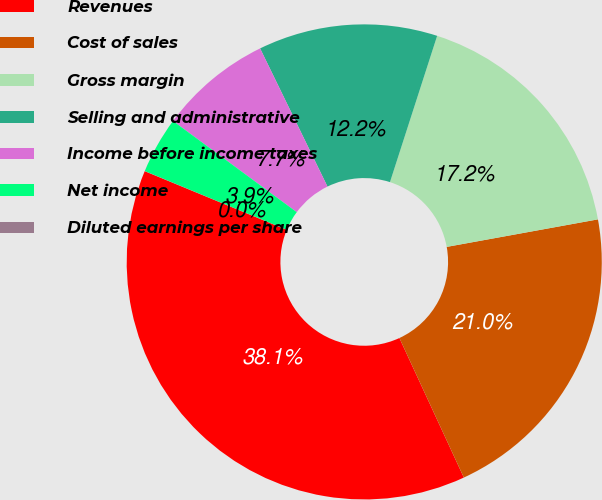Convert chart to OTSL. <chart><loc_0><loc_0><loc_500><loc_500><pie_chart><fcel>Revenues<fcel>Cost of sales<fcel>Gross margin<fcel>Selling and administrative<fcel>Income before income taxes<fcel>Net income<fcel>Diluted earnings per share<nl><fcel>38.13%<fcel>20.98%<fcel>17.17%<fcel>12.19%<fcel>7.67%<fcel>3.86%<fcel>0.01%<nl></chart> 